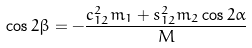<formula> <loc_0><loc_0><loc_500><loc_500>\cos 2 \beta = - \frac { c _ { 1 2 } ^ { 2 } m _ { 1 } + s _ { 1 2 } ^ { 2 } m _ { 2 } \cos 2 \alpha } { M }</formula> 